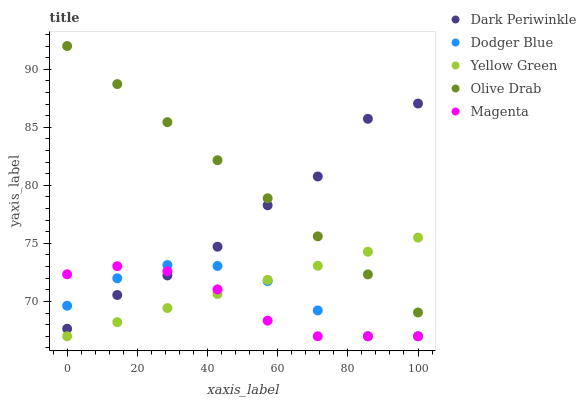Does Magenta have the minimum area under the curve?
Answer yes or no. Yes. Does Olive Drab have the maximum area under the curve?
Answer yes or no. Yes. Does Dodger Blue have the minimum area under the curve?
Answer yes or no. No. Does Dodger Blue have the maximum area under the curve?
Answer yes or no. No. Is Olive Drab the smoothest?
Answer yes or no. Yes. Is Dark Periwinkle the roughest?
Answer yes or no. Yes. Is Dodger Blue the smoothest?
Answer yes or no. No. Is Dodger Blue the roughest?
Answer yes or no. No. Does Magenta have the lowest value?
Answer yes or no. Yes. Does Dark Periwinkle have the lowest value?
Answer yes or no. No. Does Olive Drab have the highest value?
Answer yes or no. Yes. Does Dodger Blue have the highest value?
Answer yes or no. No. Is Dodger Blue less than Olive Drab?
Answer yes or no. Yes. Is Olive Drab greater than Magenta?
Answer yes or no. Yes. Does Dark Periwinkle intersect Olive Drab?
Answer yes or no. Yes. Is Dark Periwinkle less than Olive Drab?
Answer yes or no. No. Is Dark Periwinkle greater than Olive Drab?
Answer yes or no. No. Does Dodger Blue intersect Olive Drab?
Answer yes or no. No. 